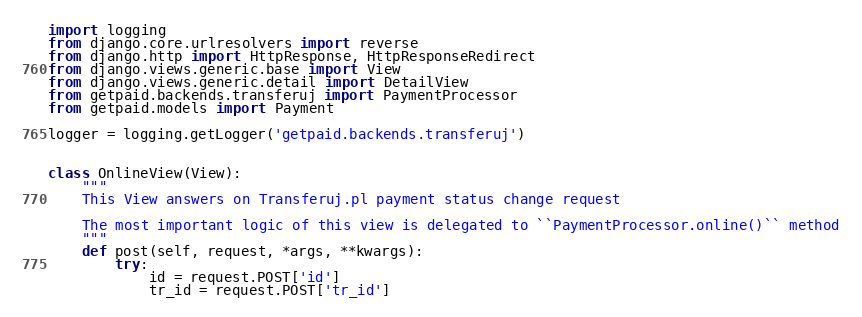Convert code to text. <code><loc_0><loc_0><loc_500><loc_500><_Python_>import logging
from django.core.urlresolvers import reverse
from django.http import HttpResponse, HttpResponseRedirect
from django.views.generic.base import View
from django.views.generic.detail import DetailView
from getpaid.backends.transferuj import PaymentProcessor
from getpaid.models import Payment

logger = logging.getLogger('getpaid.backends.transferuj')


class OnlineView(View):
    """
    This View answers on Transferuj.pl payment status change request

    The most important logic of this view is delegated to ``PaymentProcessor.online()`` method
    """
    def post(self, request, *args, **kwargs):
        try:
            id = request.POST['id']
            tr_id = request.POST['tr_id']</code> 